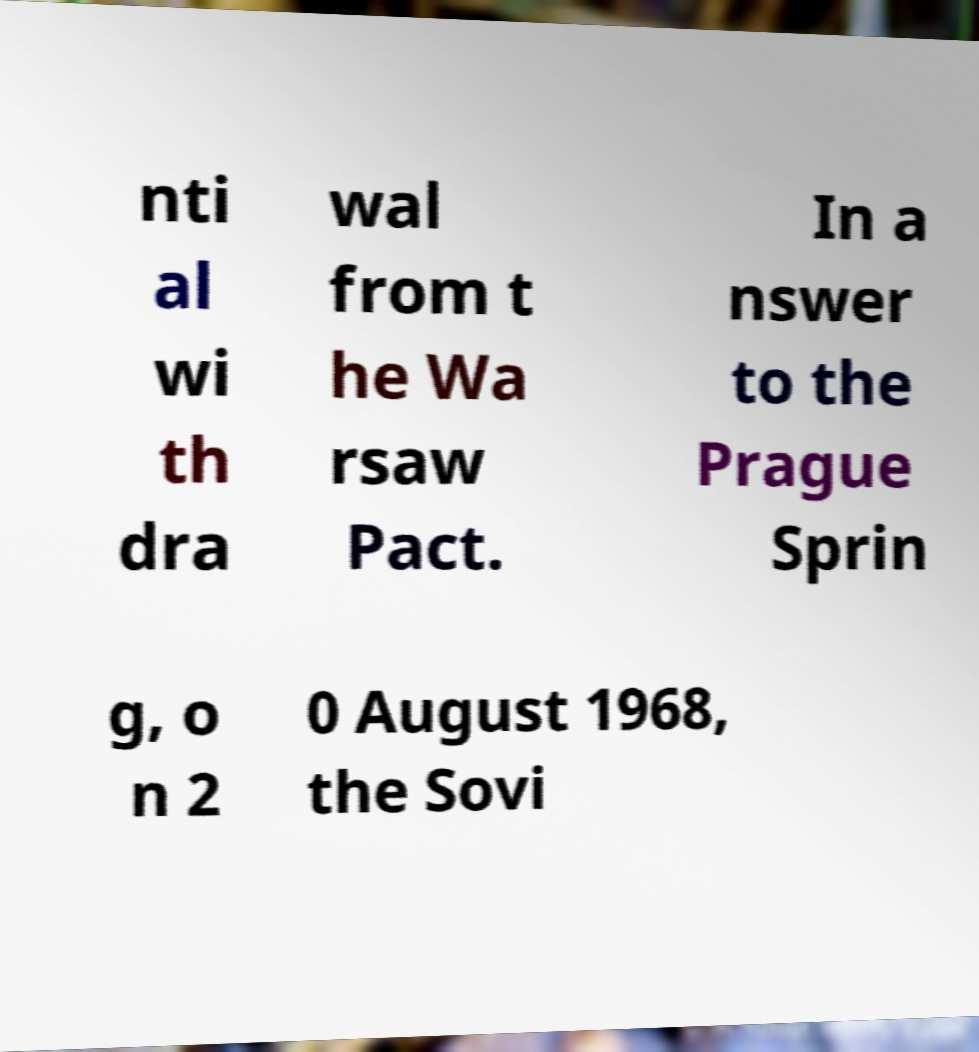Could you assist in decoding the text presented in this image and type it out clearly? nti al wi th dra wal from t he Wa rsaw Pact. In a nswer to the Prague Sprin g, o n 2 0 August 1968, the Sovi 